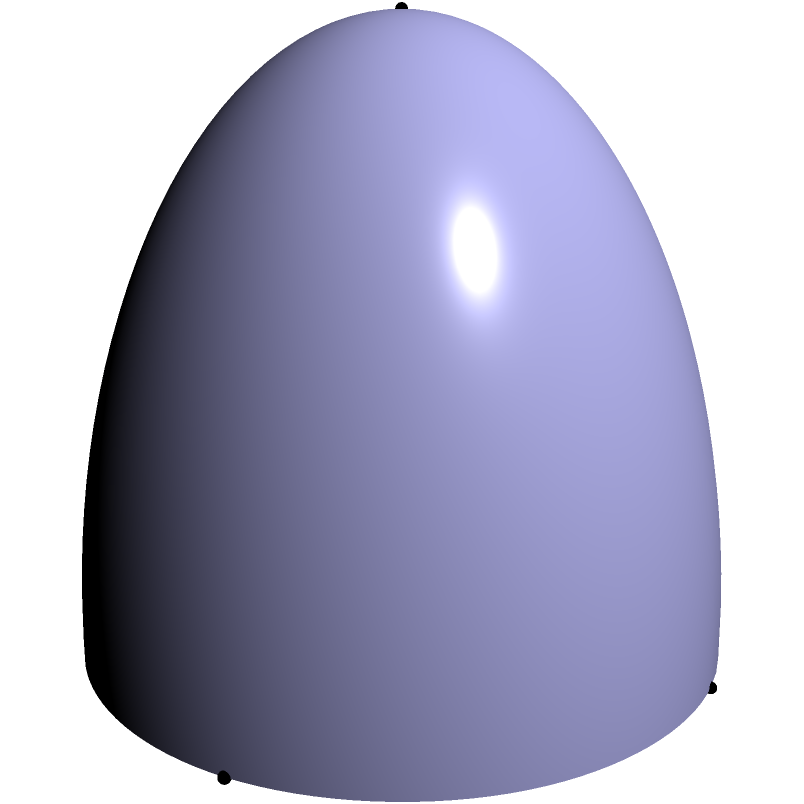You're designing a dome-shaped training facility for martial arts practitioners. The facility has a radius of 10 meters and a height of 7.5 meters. Calculate the surface area of the dome, excluding the floor. Round your answer to the nearest square meter. To calculate the surface area of a dome (excluding the floor), we can use the formula:

$$A = 2\pi rh$$

Where:
$A$ = surface area
$r$ = radius of the base
$h$ = height of the dome

Given:
$r = 10$ meters
$h = 7.5$ meters

Step 1: Substitute the values into the formula
$$A = 2\pi(10)(7.5)$$

Step 2: Calculate
$$A = 2\pi(75)$$
$$A = 150\pi$$

Step 3: Evaluate and round to the nearest square meter
$$A \approx 471.24 \text{ m}^2$$
$$A \approx 471 \text{ m}^2$$ (rounded to the nearest square meter)

Therefore, the surface area of the dome-shaped training facility is approximately 471 square meters.
Answer: 471 m² 